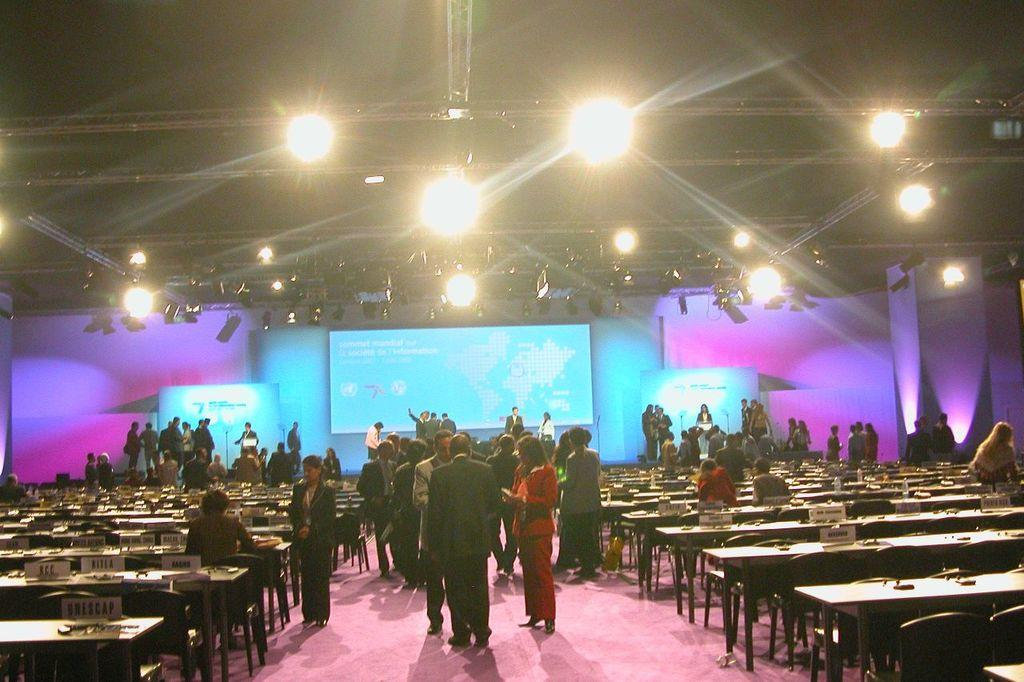How many persons are visible in the image? There are persons standing in the image. What surface are the persons standing on? The persons are standing on the floor. What type of furniture is present in the image? There are benches in the image. What can be seen in the background of the image? There is a screen and lights in the background of the image. What type of print is displayed on the hall's wall in the image? There is no mention of a hall or a print on a wall in the image. The image features persons standing on the floor, benches, and a screen with lights in the background. 